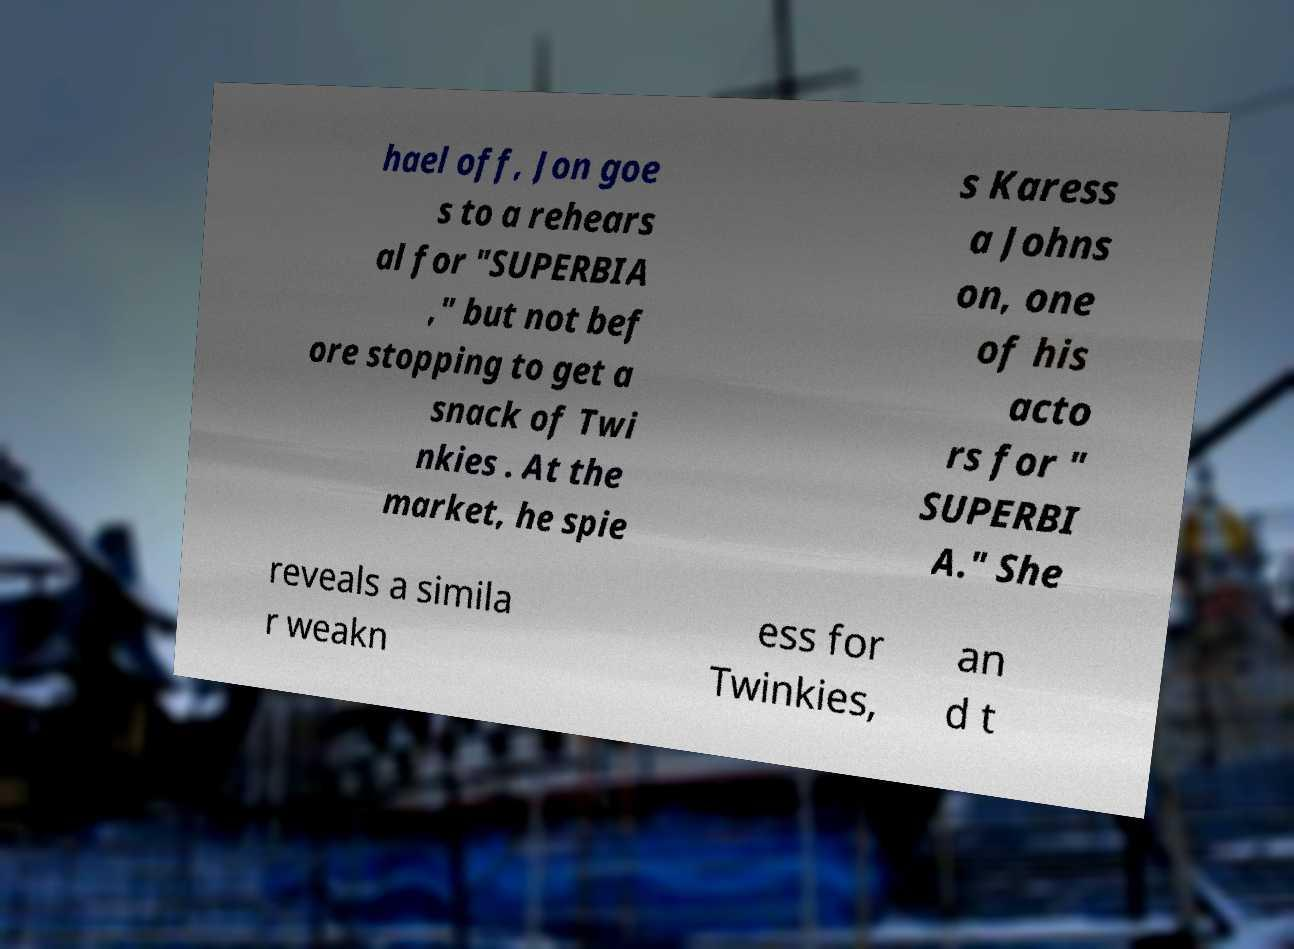There's text embedded in this image that I need extracted. Can you transcribe it verbatim? hael off, Jon goe s to a rehears al for "SUPERBIA ," but not bef ore stopping to get a snack of Twi nkies . At the market, he spie s Karess a Johns on, one of his acto rs for " SUPERBI A." She reveals a simila r weakn ess for Twinkies, an d t 